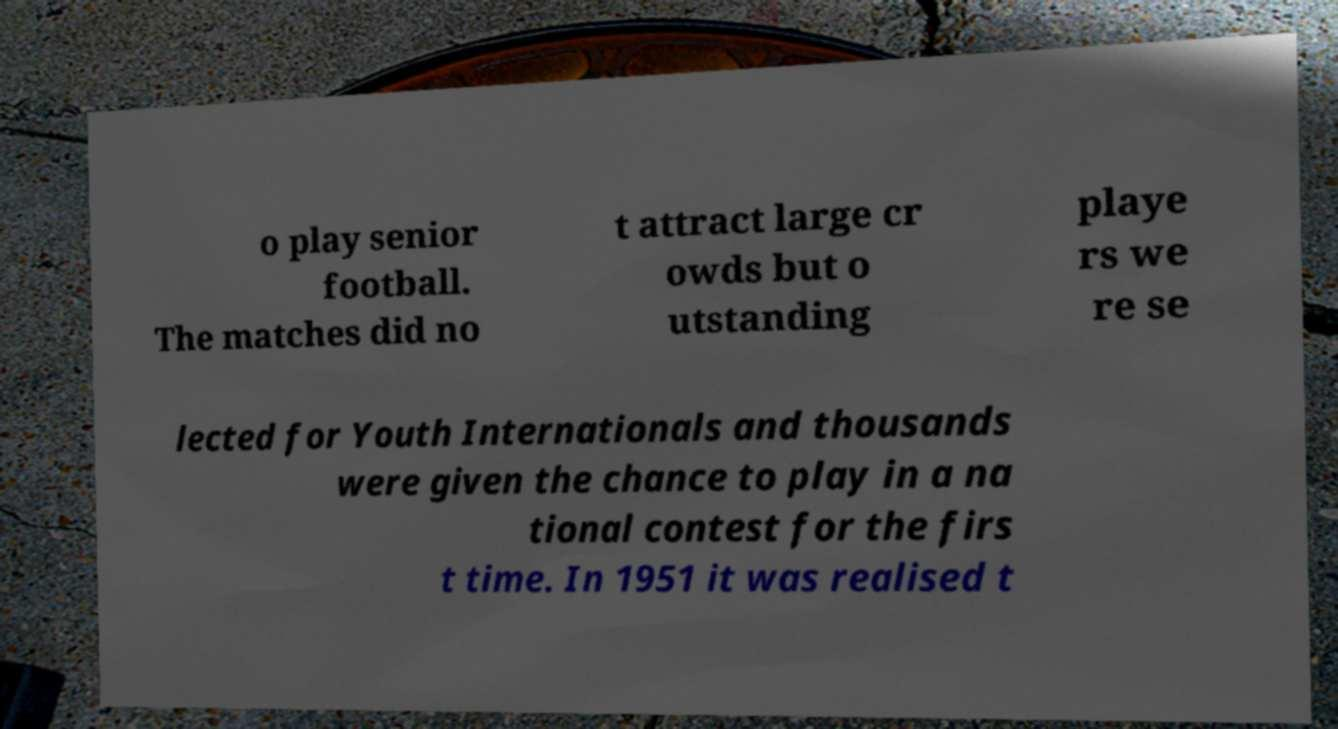I need the written content from this picture converted into text. Can you do that? o play senior football. The matches did no t attract large cr owds but o utstanding playe rs we re se lected for Youth Internationals and thousands were given the chance to play in a na tional contest for the firs t time. In 1951 it was realised t 